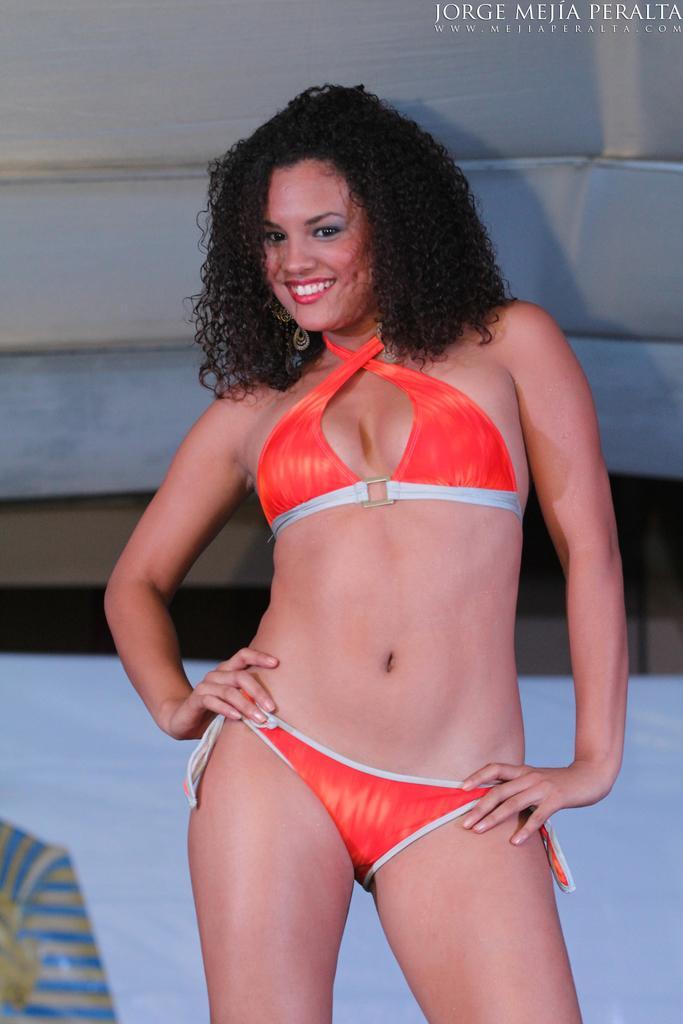Can you describe this image briefly? In this picture we can see a woman standing and smiling. There is an object in the background. We can see the text in the top right. 